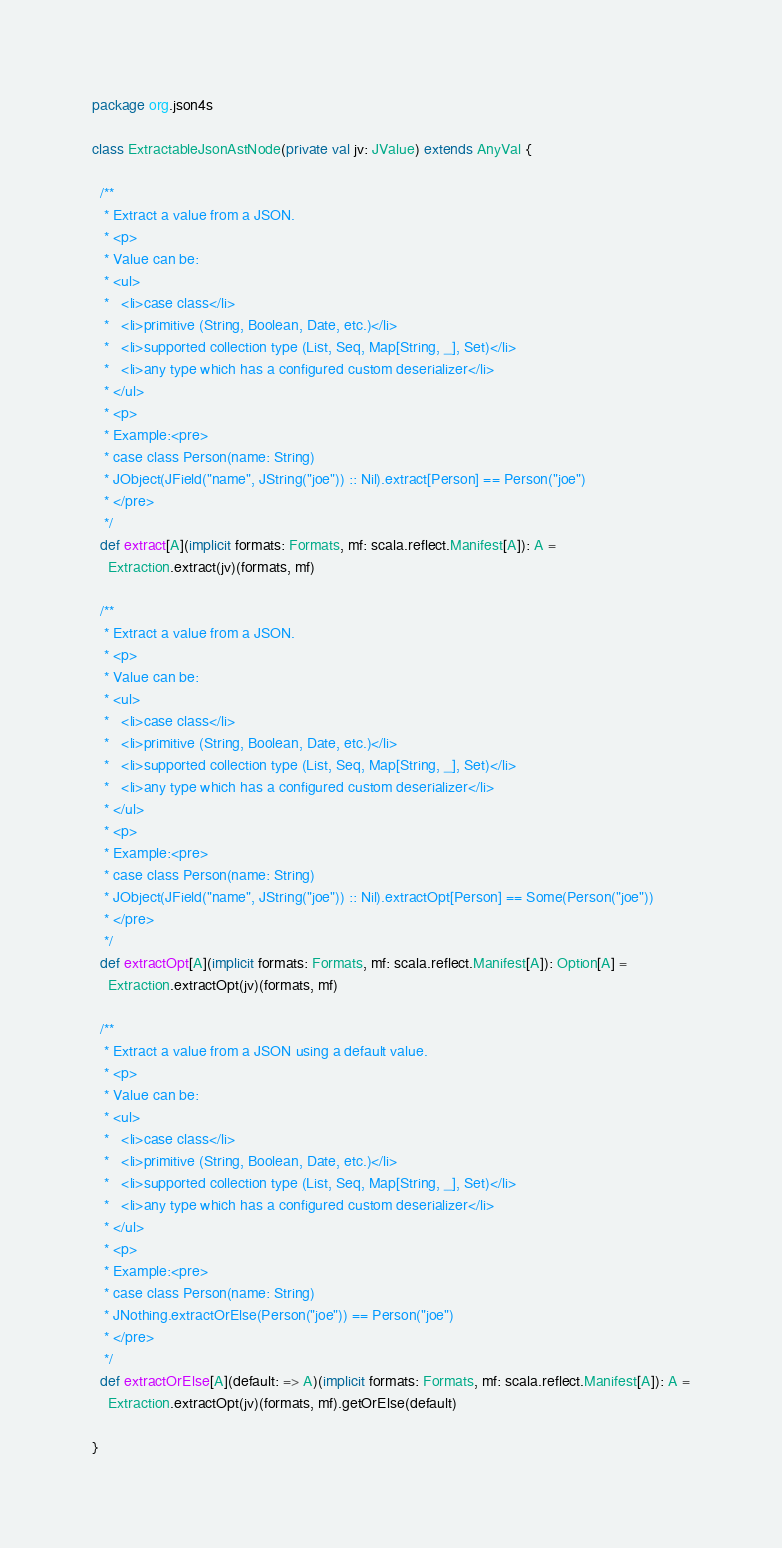<code> <loc_0><loc_0><loc_500><loc_500><_Scala_>package org.json4s

class ExtractableJsonAstNode(private val jv: JValue) extends AnyVal {

  /**
   * Extract a value from a JSON.
   * <p>
   * Value can be:
   * <ul>
   *   <li>case class</li>
   *   <li>primitive (String, Boolean, Date, etc.)</li>
   *   <li>supported collection type (List, Seq, Map[String, _], Set)</li>
   *   <li>any type which has a configured custom deserializer</li>
   * </ul>
   * <p>
   * Example:<pre>
   * case class Person(name: String)
   * JObject(JField("name", JString("joe")) :: Nil).extract[Person] == Person("joe")
   * </pre>
   */
  def extract[A](implicit formats: Formats, mf: scala.reflect.Manifest[A]): A =
    Extraction.extract(jv)(formats, mf)

  /**
   * Extract a value from a JSON.
   * <p>
   * Value can be:
   * <ul>
   *   <li>case class</li>
   *   <li>primitive (String, Boolean, Date, etc.)</li>
   *   <li>supported collection type (List, Seq, Map[String, _], Set)</li>
   *   <li>any type which has a configured custom deserializer</li>
   * </ul>
   * <p>
   * Example:<pre>
   * case class Person(name: String)
   * JObject(JField("name", JString("joe")) :: Nil).extractOpt[Person] == Some(Person("joe"))
   * </pre>
   */
  def extractOpt[A](implicit formats: Formats, mf: scala.reflect.Manifest[A]): Option[A] =
    Extraction.extractOpt(jv)(formats, mf)

  /**
   * Extract a value from a JSON using a default value.
   * <p>
   * Value can be:
   * <ul>
   *   <li>case class</li>
   *   <li>primitive (String, Boolean, Date, etc.)</li>
   *   <li>supported collection type (List, Seq, Map[String, _], Set)</li>
   *   <li>any type which has a configured custom deserializer</li>
   * </ul>
   * <p>
   * Example:<pre>
   * case class Person(name: String)
   * JNothing.extractOrElse(Person("joe")) == Person("joe")
   * </pre>
   */
  def extractOrElse[A](default: => A)(implicit formats: Formats, mf: scala.reflect.Manifest[A]): A =
    Extraction.extractOpt(jv)(formats, mf).getOrElse(default)

}
</code> 